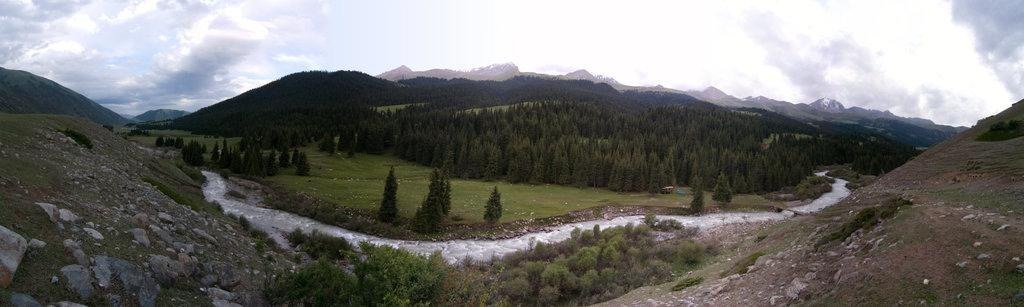What type of natural elements can be seen in the image? There are rocks, water, trees, and hills visible in the image. What part of the natural environment is visible in the image? The sky is visible in the background of the image. Where is the meeting taking place in the image? There is no meeting present in the image; it features natural elements such as rocks, water, trees, and hills. How many cats can be seen in the image? There are no cats present in the image. What type of needle can be seen in the image? There is no needle present in the image. 